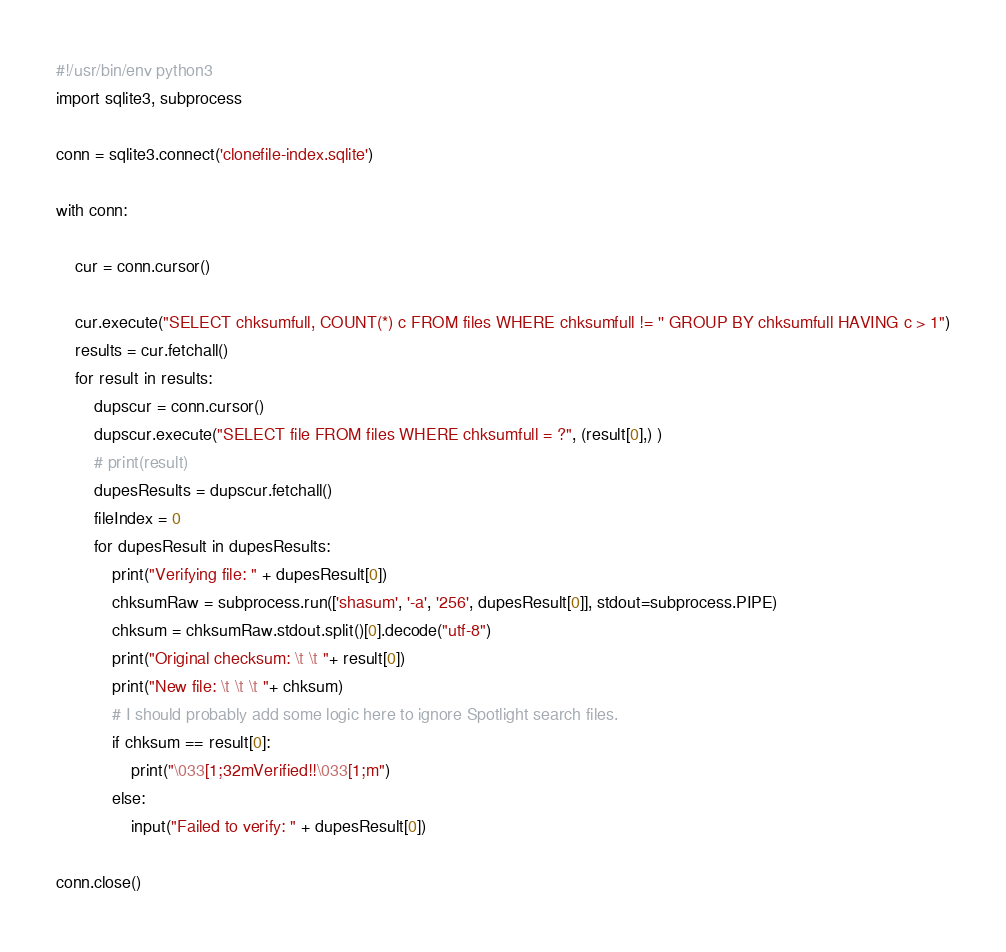Convert code to text. <code><loc_0><loc_0><loc_500><loc_500><_Python_>#!/usr/bin/env python3
import sqlite3, subprocess

conn = sqlite3.connect('clonefile-index.sqlite')

with conn:

	cur = conn.cursor()

	cur.execute("SELECT chksumfull, COUNT(*) c FROM files WHERE chksumfull != '' GROUP BY chksumfull HAVING c > 1")
	results = cur.fetchall()
	for result in results:
		dupscur = conn.cursor()
		dupscur.execute("SELECT file FROM files WHERE chksumfull = ?", (result[0],) )
		# print(result)
		dupesResults = dupscur.fetchall()
		fileIndex = 0
		for dupesResult in dupesResults:
			print("Verifying file: " + dupesResult[0])
			chksumRaw = subprocess.run(['shasum', '-a', '256', dupesResult[0]], stdout=subprocess.PIPE)
			chksum = chksumRaw.stdout.split()[0].decode("utf-8")
			print("Original checksum: \t \t "+ result[0])
			print("New file: \t \t \t "+ chksum)
			# I should probably add some logic here to ignore Spotlight search files. 
			if chksum == result[0]:
				print("\033[1;32mVerified!!\033[1;m")
			else:
				input("Failed to verify: " + dupesResult[0])

conn.close()
</code> 